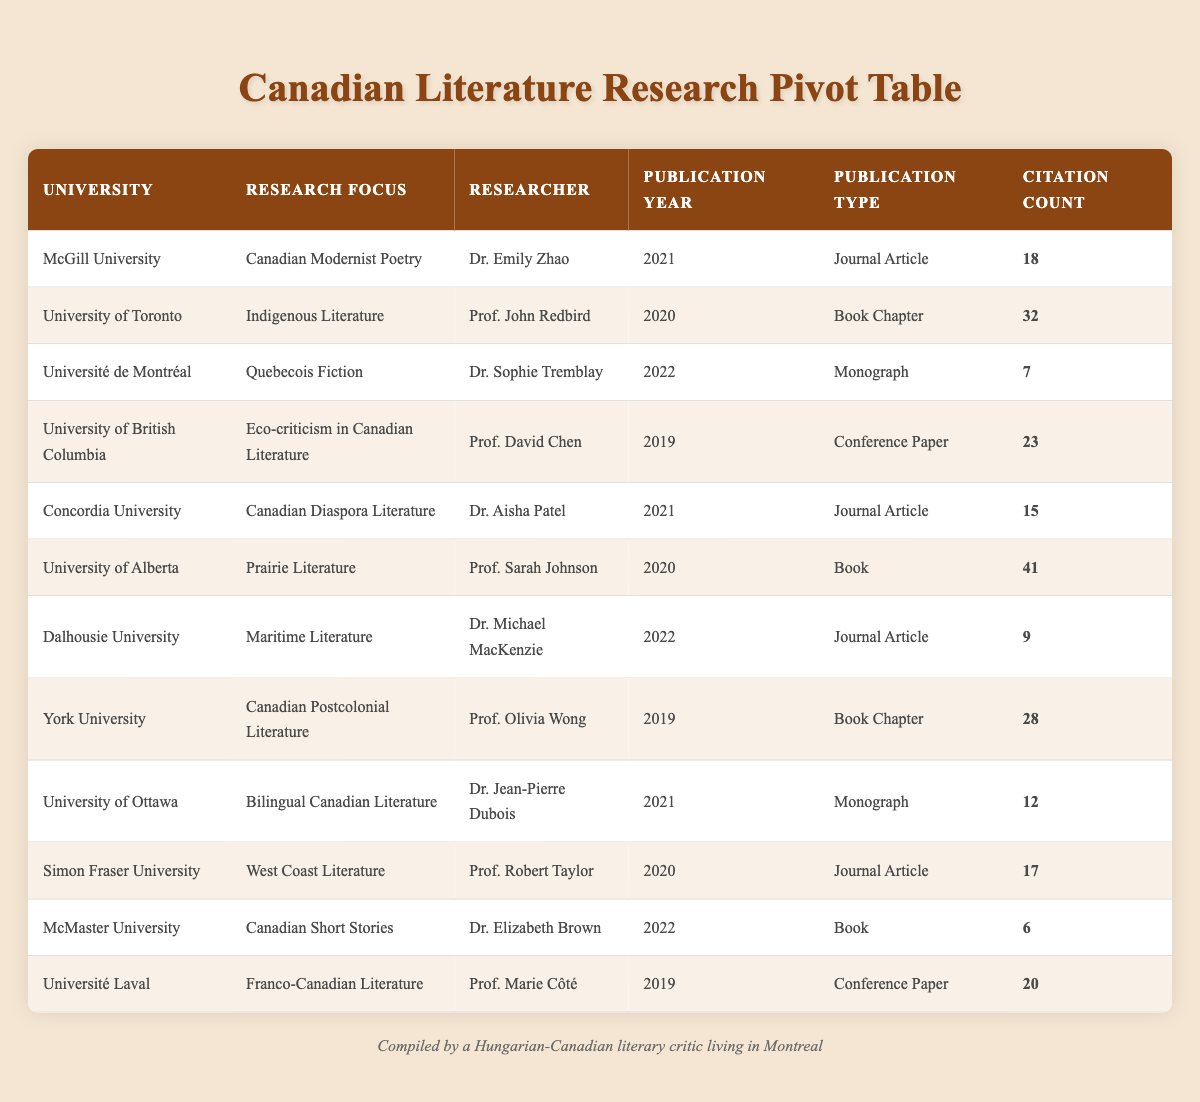What is the highest citation count among the publications listed? The highest citation count can be found by scanning the "Citation Count" column for the maximum value. After reviewing the table, I see that the University of Alberta has a citation count of 41, which is the highest.
Answer: 41 Which publication type has the most research focus entries in the table? By looking at the "Publication Type" column, I can tally the entries for each type. Journal Articles have 5 entries, Book Chapters have 3, Monographs have 2, Books have 2, and Conference Papers have 2. Therefore, Journal Articles have the most entries.
Answer: Journal Article Did any researcher from McGill University publish work in the year 2020? A check of the rows for McGill University shows only one publication from Dr. Emily Zhao in 2021. Since there are no entries for the year 2020, the answer is no.
Answer: No What is the average citation count for the publications related to poetry? I check the "Research Focus" column to identify all entries related to poetry, which only includes Dr. Emily Zhao's work (18 citations from McGill University). Since there's only one entry, the average citation count is simply that value.
Answer: 18 Which university contributed the least number of citations in their publication? To find the least citations, I compare the citation counts from each university's publication. The lowest citation count is from McMaster University with 6.
Answer: McMaster University How many different research focuses are explored by universities in the table? I analyze the distinct "Research Focus" entries listed. Counting the unique research focuses gives me 11 distinct focuses, as seen in the table.
Answer: 11 Is there a publication from the University of Ottawa that received more than 10 citations? Checking the University of Ottawa entry, Dr. Jean-Pierre Dubois has a publication in 2021 with 12 citations, which is more than 10. Therefore, the answer is yes.
Answer: Yes What is the total number of citation counts for all publications related to Indigenous Literature? I look for the "Research Focus" related to Indigenous Literature. The University of Toronto's entry shows Prof. John Redbird's publication has 32 citations. Since it's the only entry, the total is simply 32.
Answer: 32 Which researcher has the highest citation count for their work in the field of Maritime Literature? I consult the specific entry for Maritime Literature, which is from Dr. Michael MacKenzie at Dalhousie University with 9 citations. Since this is the only publication in that field, it establishes that count.
Answer: 9 